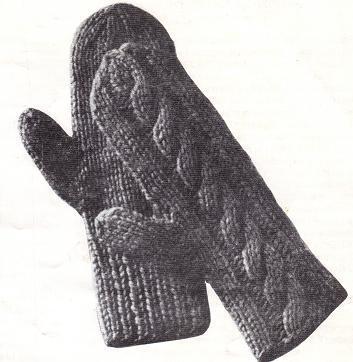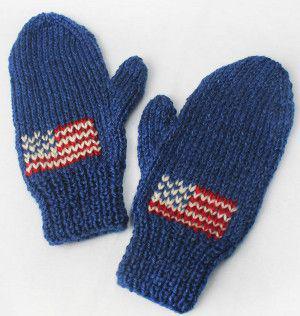The first image is the image on the left, the second image is the image on the right. Evaluate the accuracy of this statement regarding the images: "One of the pairs of mittens is gray knit with a vertical braid-like pattern running its length.". Is it true? Answer yes or no. Yes. The first image is the image on the left, the second image is the image on the right. Considering the images on both sides, is "The mittens in the image on the left are made of a solid color." valid? Answer yes or no. Yes. 